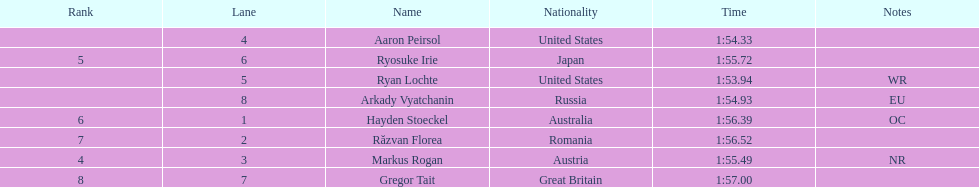Did austria or russia rank higher? Russia. 